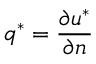Convert formula to latex. <formula><loc_0><loc_0><loc_500><loc_500>q ^ { * } = \frac { \partial u ^ { * } } { \partial n }</formula> 